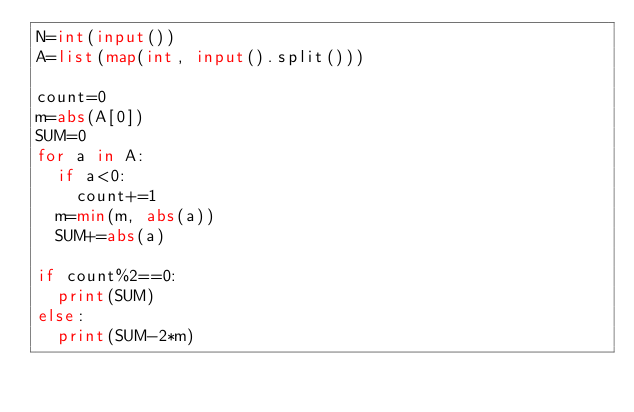Convert code to text. <code><loc_0><loc_0><loc_500><loc_500><_Python_>N=int(input())
A=list(map(int, input().split()))

count=0
m=abs(A[0])
SUM=0
for a in A:
  if a<0:
    count+=1
  m=min(m, abs(a))
  SUM+=abs(a)

if count%2==0:
  print(SUM)
else:
  print(SUM-2*m)</code> 